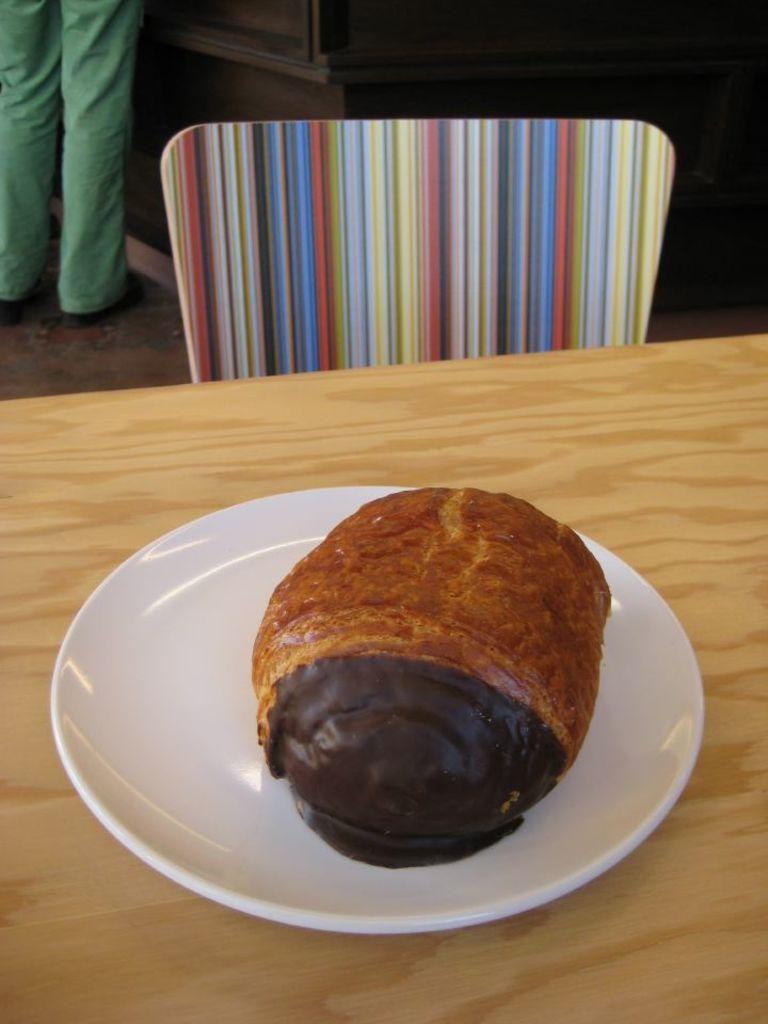Describe this image in one or two sentences. In this image I can see the food and the food is in brown color. The food is in the white color plate and the plate is on the table. Background I can see the chair and I can also see the person standing and the person is wearing green color dress. 